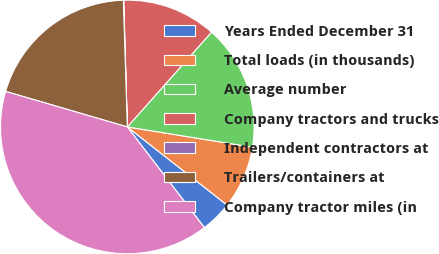<chart> <loc_0><loc_0><loc_500><loc_500><pie_chart><fcel>Years Ended December 31<fcel>Total loads (in thousands)<fcel>Average number<fcel>Company tractors and trucks<fcel>Independent contractors at<fcel>Trailers/containers at<fcel>Company tractor miles (in<nl><fcel>4.03%<fcel>8.02%<fcel>15.99%<fcel>12.01%<fcel>0.05%<fcel>19.98%<fcel>39.92%<nl></chart> 